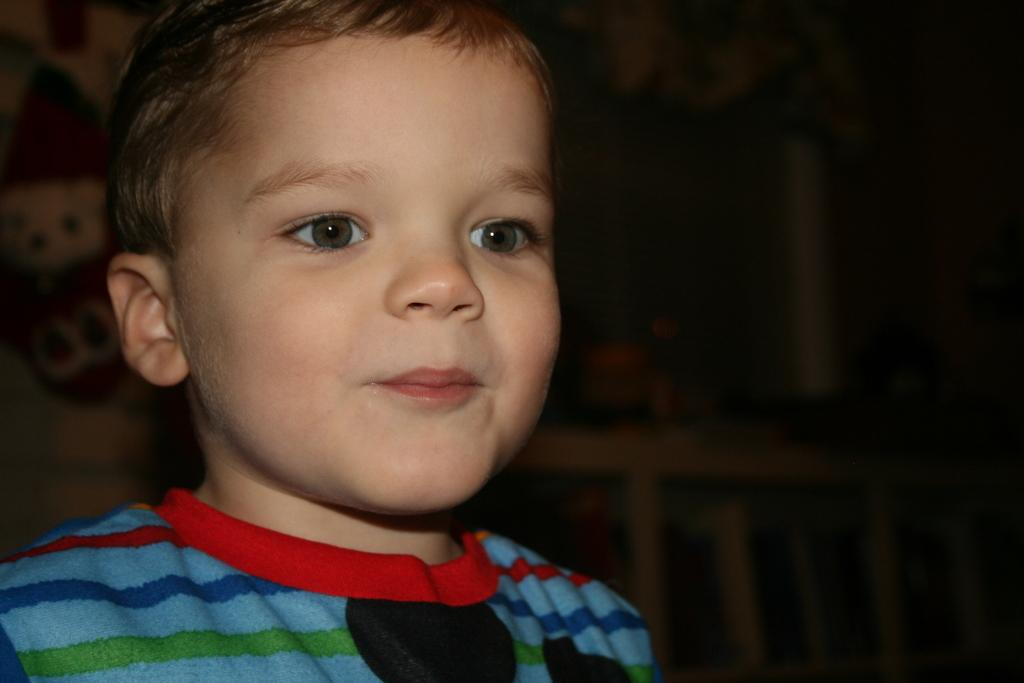Who is the main subject in the image? There is a boy in the image. What can be seen behind the boy? There is a toy behind the boy. What is the color of the background in the image? The background of the image is dark. What type of cast can be seen on the boy's arm in the image? There is no cast visible on the boy's arm in the image. What is the boy using to play with the toy in the image? The provided facts do not mention any specific object or tool the boy is using to play with the toy. 